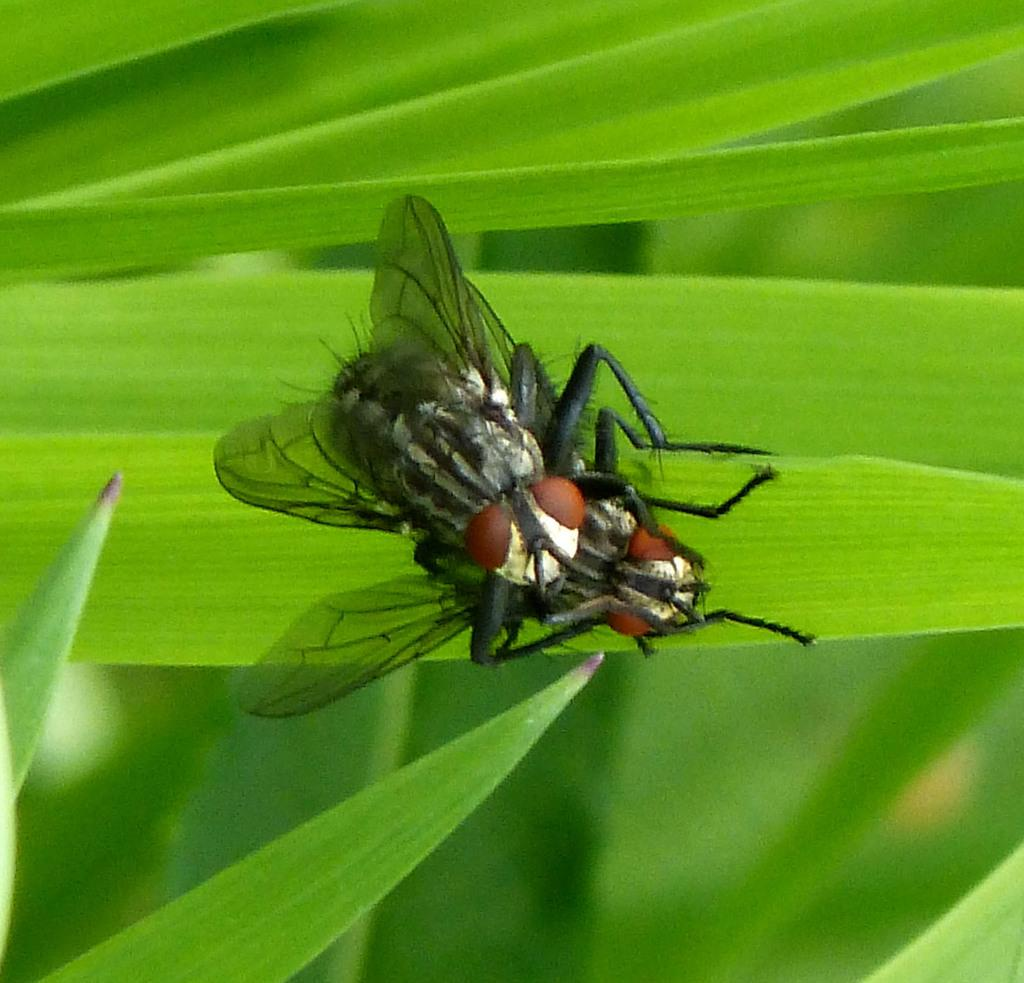What insects are present in the image? There are two house flies in the image. What are the house flies resting on? The house flies are on green color leaves. What is the dominant color in the image? The background of the image is green in color. How is the image's focus distributed? The image is blurred in the background. What type of bean is visible on the paper in the image? There is no bean or paper present in the image; it features two house flies on green leaves. 